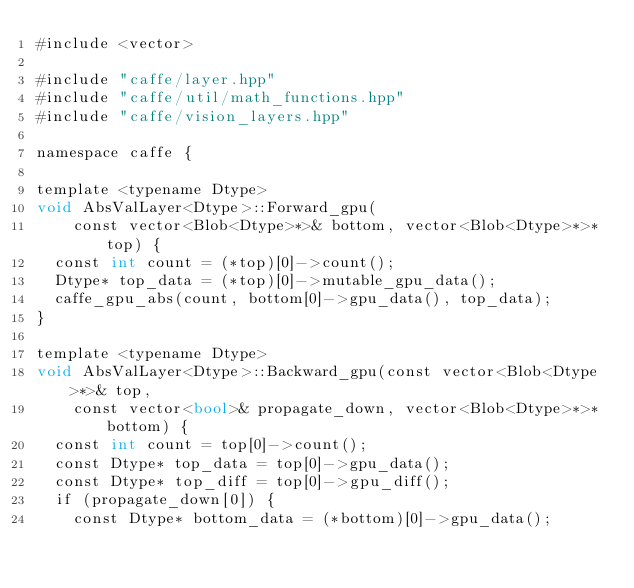Convert code to text. <code><loc_0><loc_0><loc_500><loc_500><_Cuda_>#include <vector>

#include "caffe/layer.hpp"
#include "caffe/util/math_functions.hpp"
#include "caffe/vision_layers.hpp"

namespace caffe {

template <typename Dtype>
void AbsValLayer<Dtype>::Forward_gpu(
    const vector<Blob<Dtype>*>& bottom, vector<Blob<Dtype>*>* top) {
  const int count = (*top)[0]->count();
  Dtype* top_data = (*top)[0]->mutable_gpu_data();
  caffe_gpu_abs(count, bottom[0]->gpu_data(), top_data);
}

template <typename Dtype>
void AbsValLayer<Dtype>::Backward_gpu(const vector<Blob<Dtype>*>& top,
    const vector<bool>& propagate_down, vector<Blob<Dtype>*>* bottom) {
  const int count = top[0]->count();
  const Dtype* top_data = top[0]->gpu_data();
  const Dtype* top_diff = top[0]->gpu_diff();
  if (propagate_down[0]) {
    const Dtype* bottom_data = (*bottom)[0]->gpu_data();</code> 